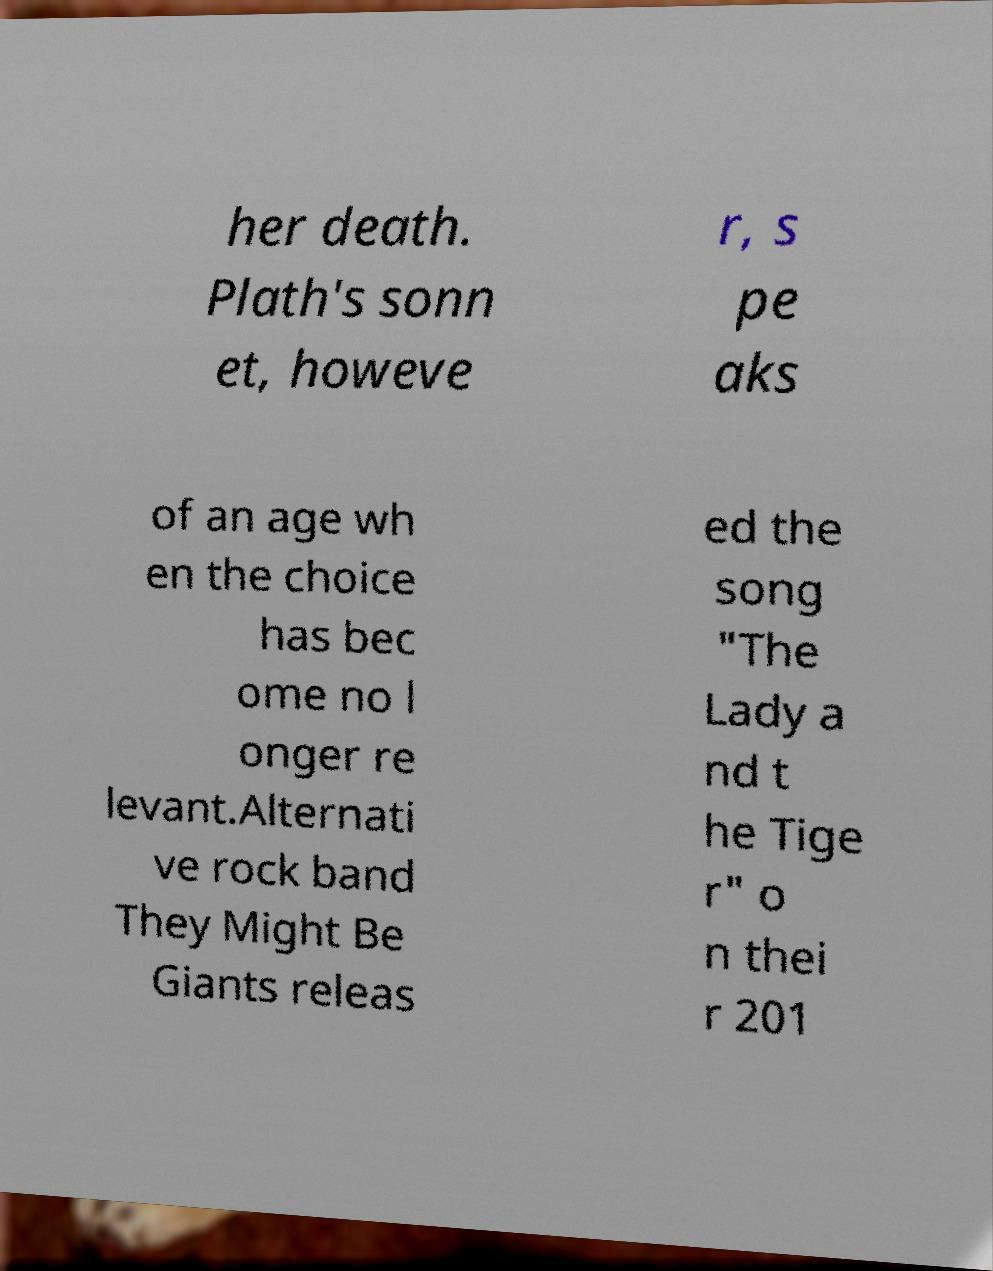I need the written content from this picture converted into text. Can you do that? her death. Plath's sonn et, howeve r, s pe aks of an age wh en the choice has bec ome no l onger re levant.Alternati ve rock band They Might Be Giants releas ed the song "The Lady a nd t he Tige r" o n thei r 201 